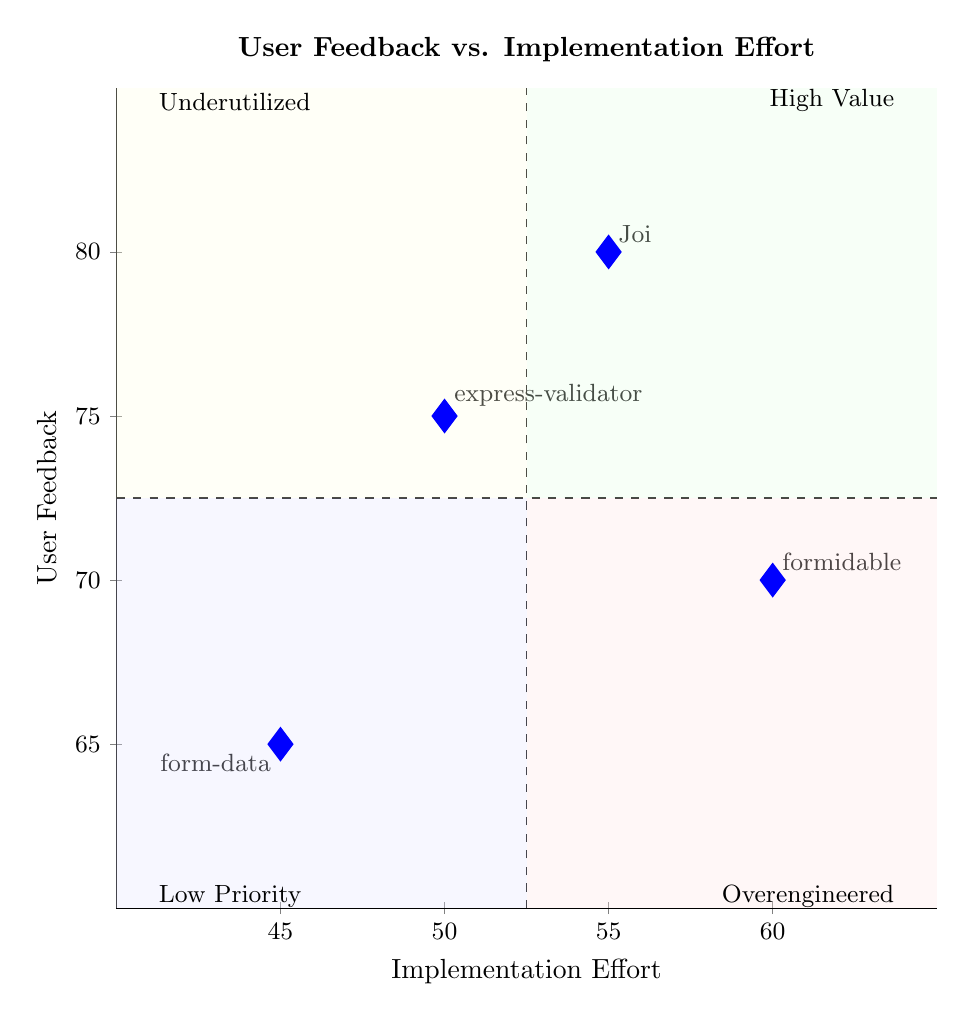What is the user feedback score for Joi? The diagram indicates that Joi is located at the coordinate (55, 80), where the y-value represents user feedback. Therefore, the user feedback score for Joi is 80.
Answer: 80 What is the implementation effort for form-data? From the coordinates of form-data, identified in the diagram as (45, 65), the x-value represents the implementation effort. Hence, the implementation effort for form-data is 45.
Answer: 45 Which library has the highest user feedback? The library with the highest y-coordinate in the diagram is Joi, positioned at (55, 80). Therefore, the library with the highest user feedback is Joi.
Answer: Joi What quadrant is express-validator located in? Express-validator is at the coordinates (50, 75). Since it has a user feedback score of 75 (high) and implementation effort of 50 (average), it falls in Quadrant 1, which is for high value solutions.
Answer: Quadrant 1 What is the lowest implementation effort score among the libraries? By reviewing the x-values of the libraries plotted in the diagram, form-data has the lowest implementation effort at 45. Hence, the lowest implementation effort score is 45.
Answer: 45 How many libraries are positioned in Quadrant 1? To determine this, we check which libraries have both high user feedback (above 72.5) and low implementation effort (below 52.5). Only Joi and express-validator fit this criterion, resulting in a total of 2 libraries in Quadrant 1.
Answer: 2 Which library has the least amount of positive user feedback? Among the libraries, form-data has the lowest user feedback score of 65, located at (45, 65) in the diagram. Thus, the library with the least positive user feedback is form-data.
Answer: form-data What is the user feedback score for formidable? The coordinates for formidable are (60, 70), where the y-value represents user feedback. Therefore, the user feedback score for formidable is 70.
Answer: 70 What does the dashed line at x=52.5 signify in the diagram? The dashed line at x=52.5 divides the chart, indicating the threshold for implementation effort, where libraries to the left require less effort, and those to the right require more.
Answer: Threshold for implementation effort 